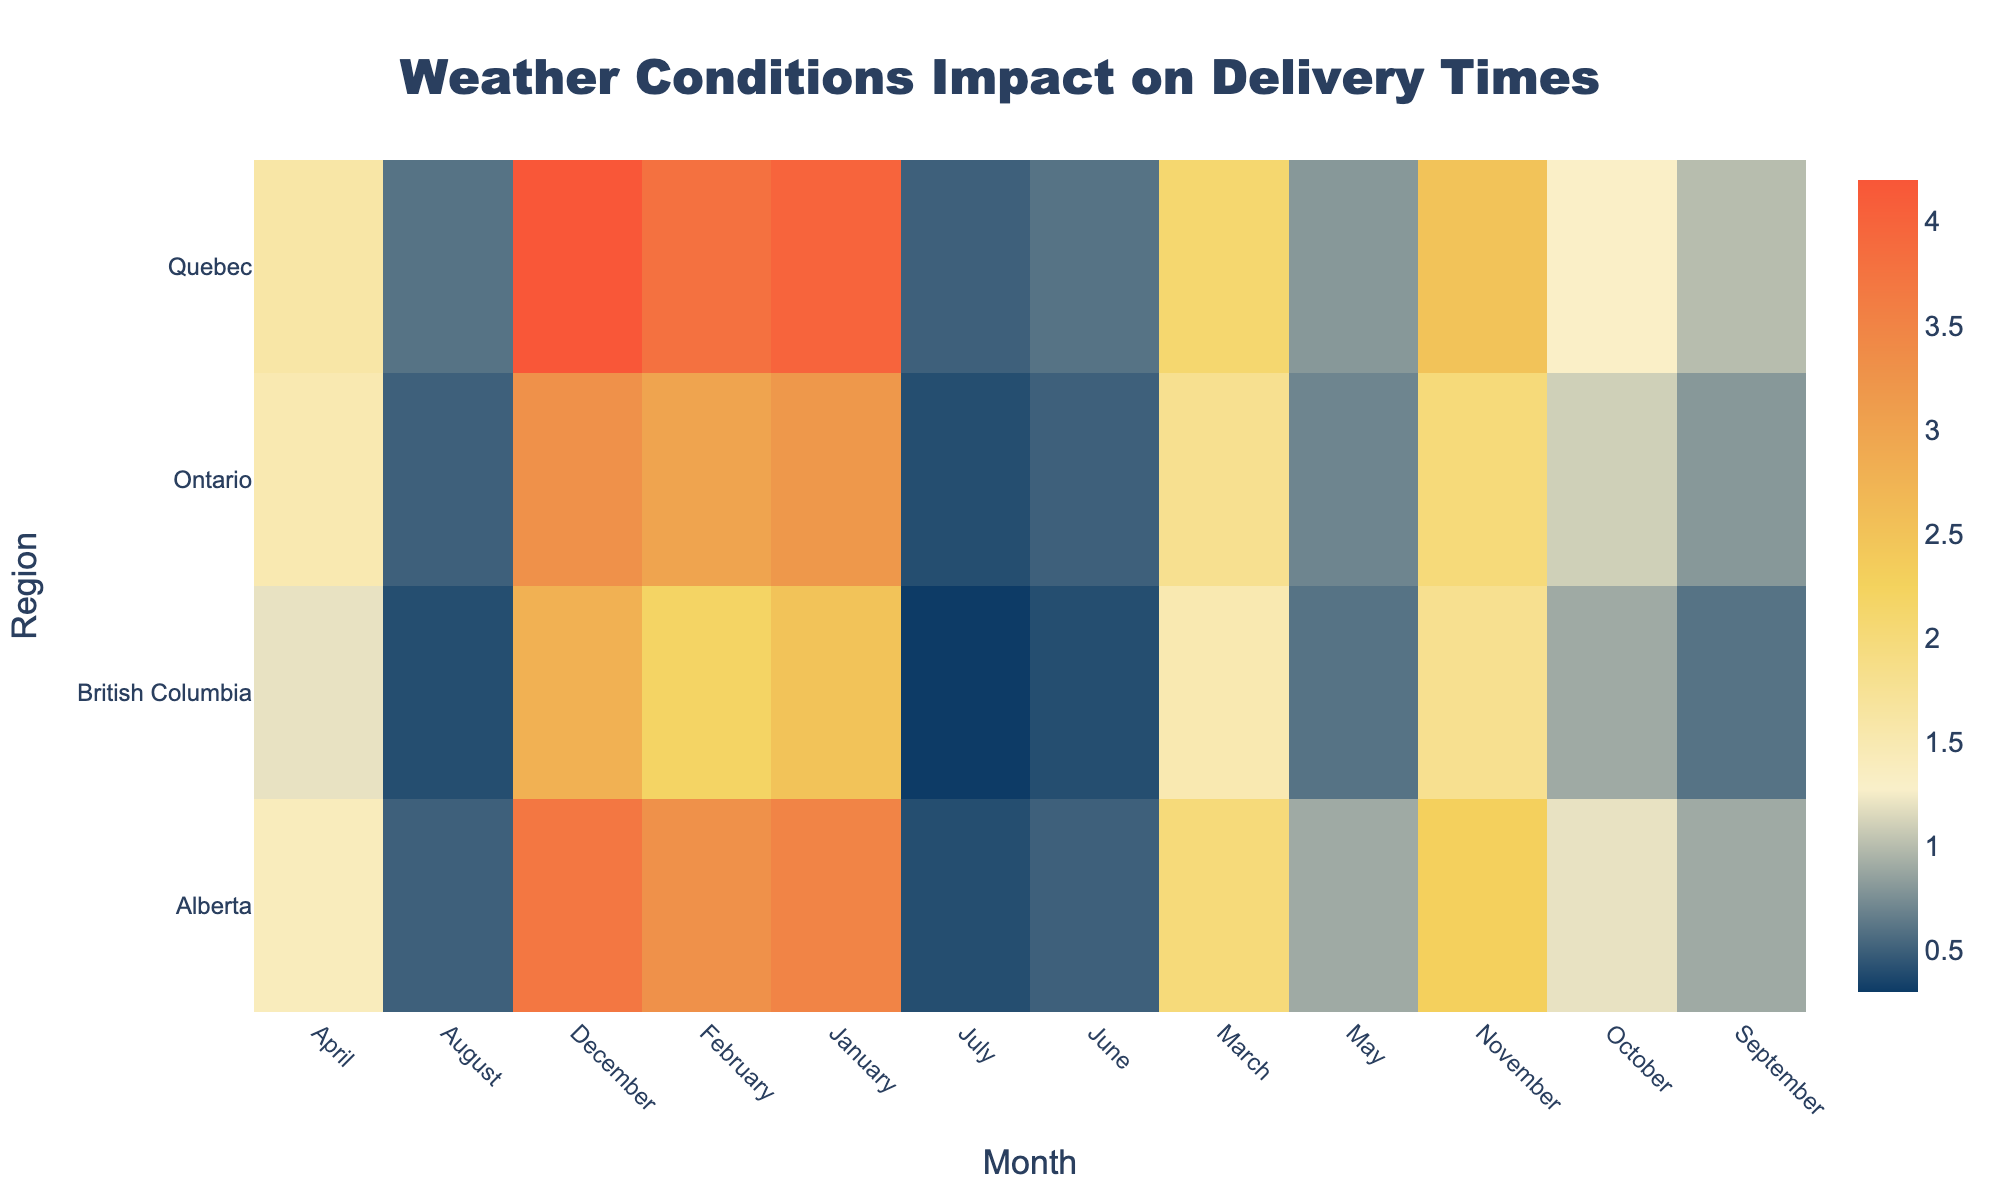what is the title of the figure? The title of the figure is shown at the top and is usually larger in font size for easy readability.
Answer: Weather Conditions Impact on Delivery Times which region has the highest average delay in December? By locating the December column and comparing the values across different regions, the highest value is observed in Quebec.
Answer: Quebec when is the lowest average delay in Ontario? Looking at the Ontario row across all months, the lowest value is recorded in July with an average delay of 0.4 hours.
Answer: July compare the average delay in British Columbia in January and February. Which month has a lower delay? Observing the values for British Columbia in January and February, January has a delay of 2.5 hours and February has a delay of 2.2 hours. February has a lower delay.
Answer: February what is the range of average delays in Alberta throughout the year? The range is calculated by subtracting the minimum delay value from the maximum delay value in Alberta. The maximum is 3.7 hours (December) and the minimum is 0.4 hours (July), giving a range of 3.3 hours.
Answer: 3.3 hours which two months in Quebec have the same average delay? Examining the Quebec row, May and August both have an average delay of 0.6 hours.
Answer: May and August what is the sum of average delays in Ontario for January and November? Adding the average delays for January (3.2 hours) and November (2.0 hours) in Ontario gives a total of 5.2 hours.
Answer: 5.2 hours how does the average delay in April compare between Ontario and Alberta? Comparing April values, Ontario has an average delay of 1.5 hours and Alberta has an average delay of 1.4 hours. Ontario has a slightly higher average delay.
Answer: Ontario during which months does British Columbia experience an average delay of less than 1 hour? Observing the British Columbia row, the months with average delays less than 1 hour are May, June, July, August, and September.
Answer: May, June, July, August, and September what is the average delay across all regions in February? To get the average, sum the February values for all regions (3.0 + 3.8 + 2.2 + 3.3 = 12.3 hours) and divide by the number of regions (4). The average is 12.3/4 = 3.075 hours.
Answer: 3.075 hours 